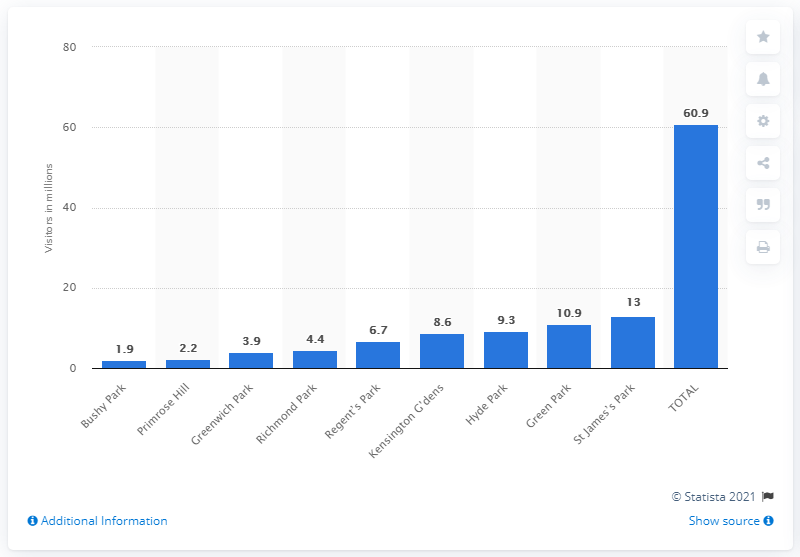Give some essential details in this illustration. In 2014, the number of visitors to St. James's Park was 13. In 2014, approximately 60.9 people visited the Royal Parks. 